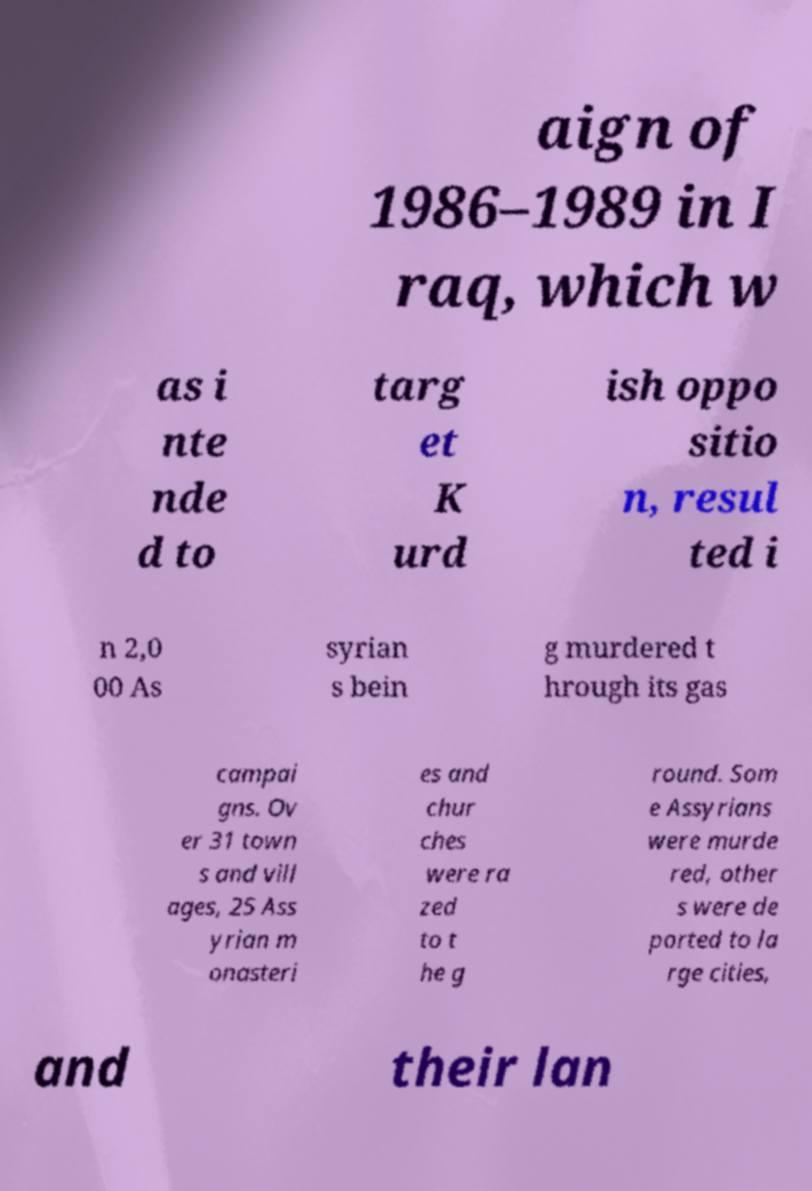Please read and relay the text visible in this image. What does it say? aign of 1986–1989 in I raq, which w as i nte nde d to targ et K urd ish oppo sitio n, resul ted i n 2,0 00 As syrian s bein g murdered t hrough its gas campai gns. Ov er 31 town s and vill ages, 25 Ass yrian m onasteri es and chur ches were ra zed to t he g round. Som e Assyrians were murde red, other s were de ported to la rge cities, and their lan 